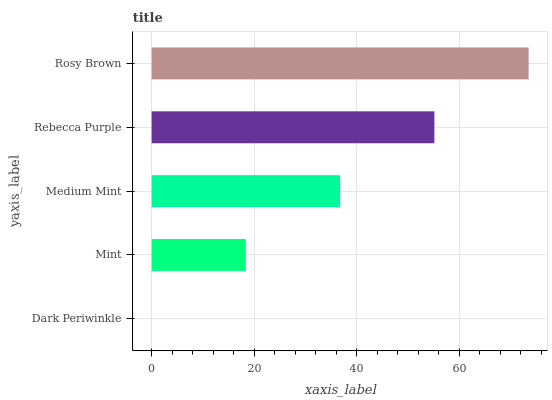Is Dark Periwinkle the minimum?
Answer yes or no. Yes. Is Rosy Brown the maximum?
Answer yes or no. Yes. Is Mint the minimum?
Answer yes or no. No. Is Mint the maximum?
Answer yes or no. No. Is Mint greater than Dark Periwinkle?
Answer yes or no. Yes. Is Dark Periwinkle less than Mint?
Answer yes or no. Yes. Is Dark Periwinkle greater than Mint?
Answer yes or no. No. Is Mint less than Dark Periwinkle?
Answer yes or no. No. Is Medium Mint the high median?
Answer yes or no. Yes. Is Medium Mint the low median?
Answer yes or no. Yes. Is Rebecca Purple the high median?
Answer yes or no. No. Is Mint the low median?
Answer yes or no. No. 